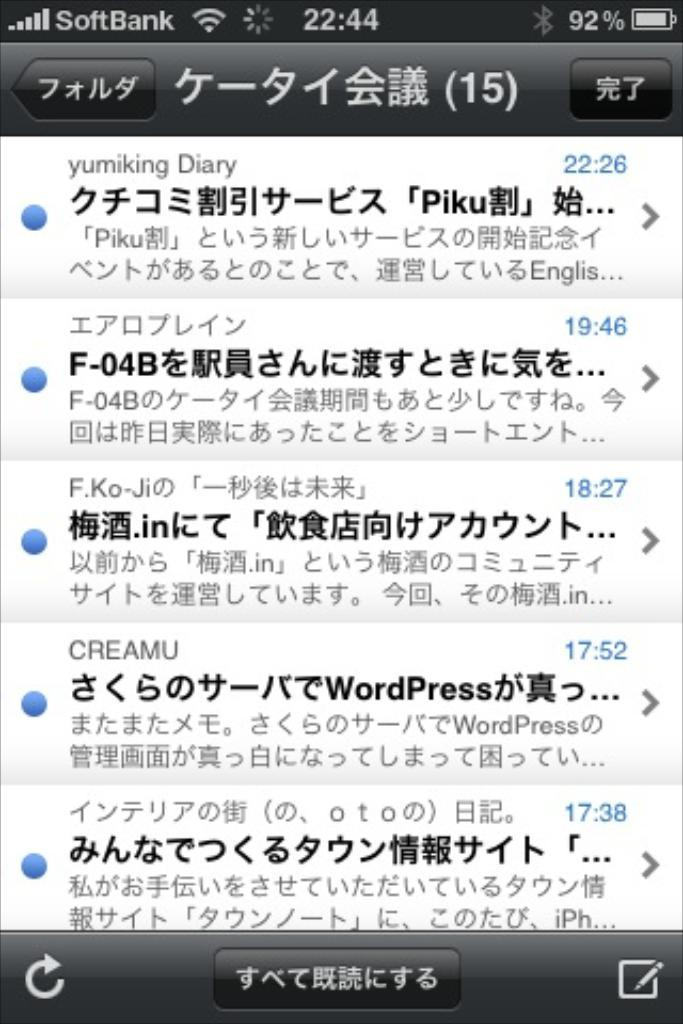<image>
Create a compact narrative representing the image presented. The screenshot from a phone are texts or emails in a foreign language. 